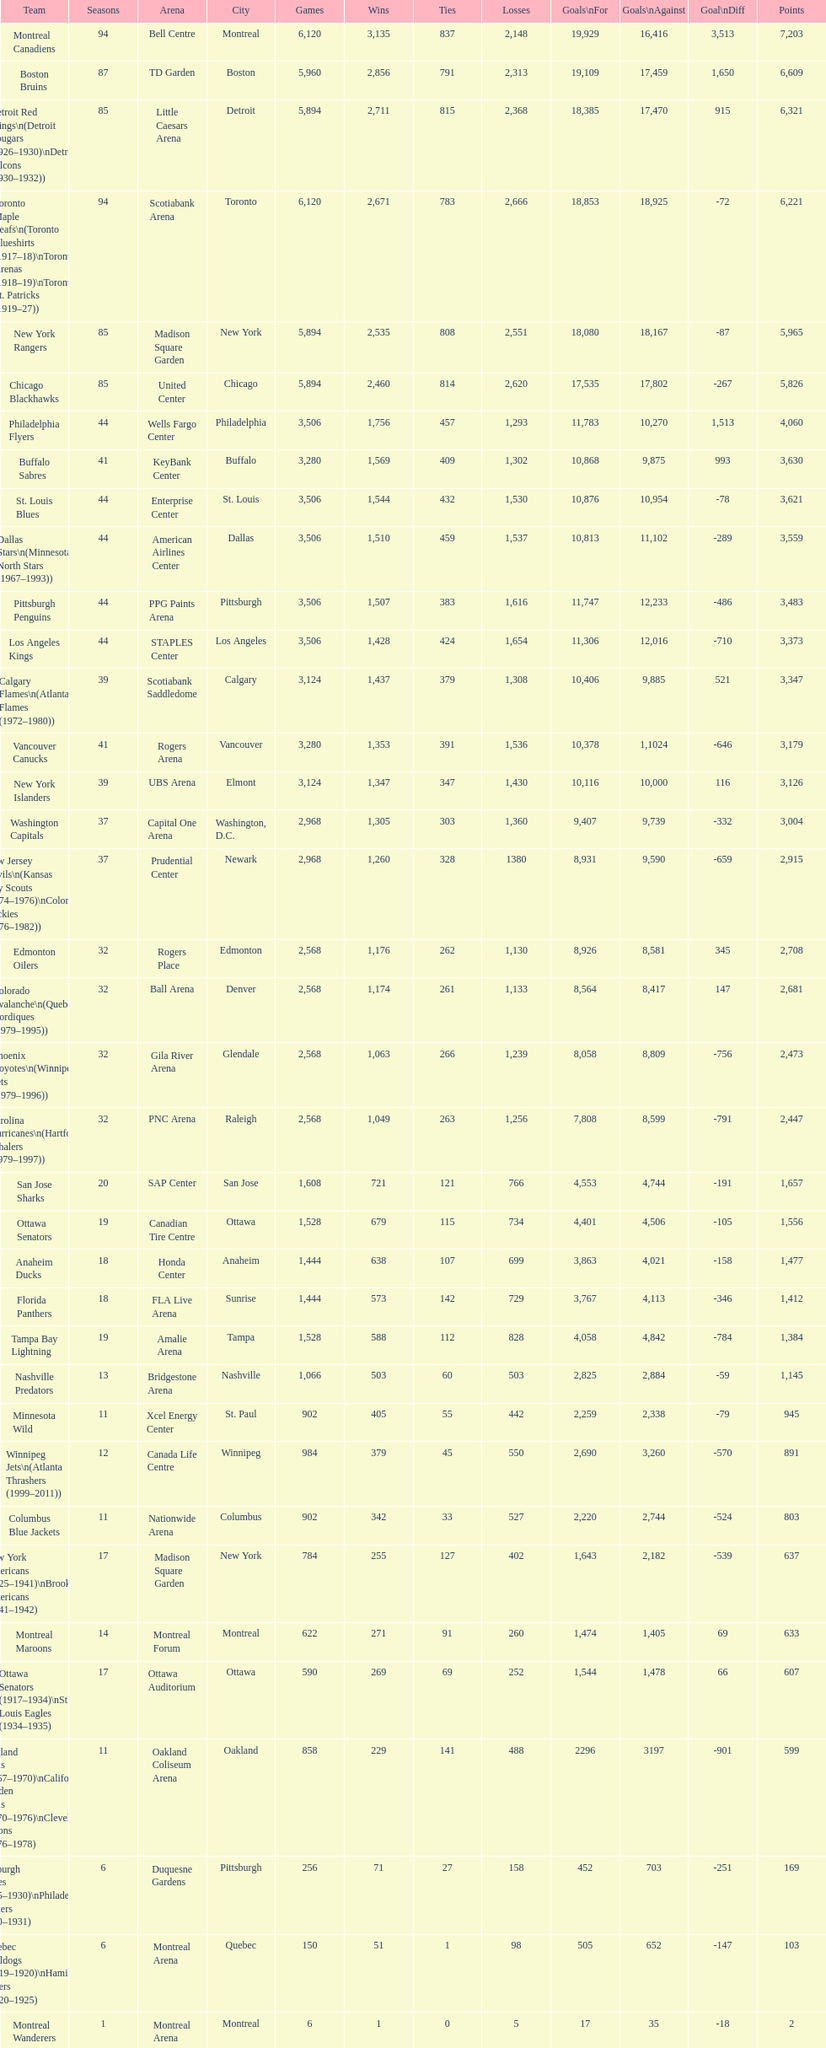Which team played the same amount of seasons as the canadiens? Toronto Maple Leafs. 